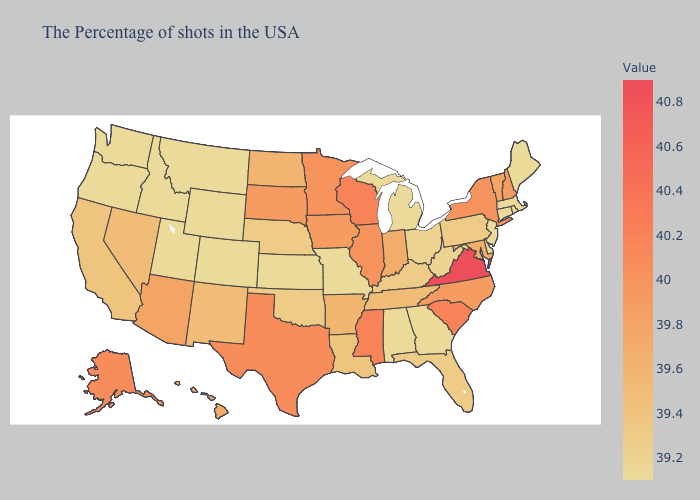Among the states that border Colorado , does Wyoming have the lowest value?
Be succinct. Yes. Does Indiana have the lowest value in the USA?
Concise answer only. No. Which states have the lowest value in the Northeast?
Be succinct. Maine, Massachusetts, Rhode Island, Connecticut, New Jersey. Does Florida have the lowest value in the USA?
Give a very brief answer. No. Which states have the highest value in the USA?
Keep it brief. Virginia. Among the states that border South Dakota , which have the highest value?
Write a very short answer. Minnesota. Does Indiana have the highest value in the USA?
Keep it brief. No. 